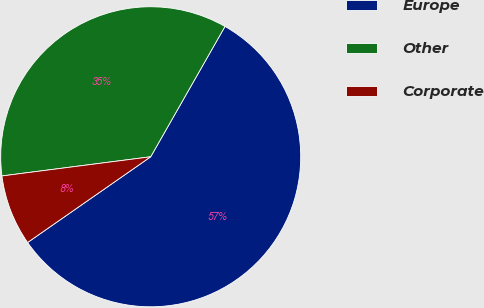<chart> <loc_0><loc_0><loc_500><loc_500><pie_chart><fcel>Europe<fcel>Other<fcel>Corporate<nl><fcel>57.07%<fcel>35.29%<fcel>7.64%<nl></chart> 